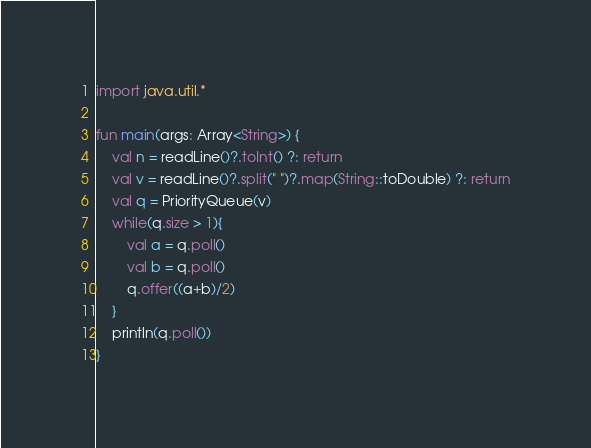Convert code to text. <code><loc_0><loc_0><loc_500><loc_500><_Kotlin_>import java.util.*

fun main(args: Array<String>) {
    val n = readLine()?.toInt() ?: return
    val v = readLine()?.split(" ")?.map(String::toDouble) ?: return
    val q = PriorityQueue(v)
    while(q.size > 1){
        val a = q.poll()
        val b = q.poll()
        q.offer((a+b)/2)
    }
    println(q.poll())
}</code> 